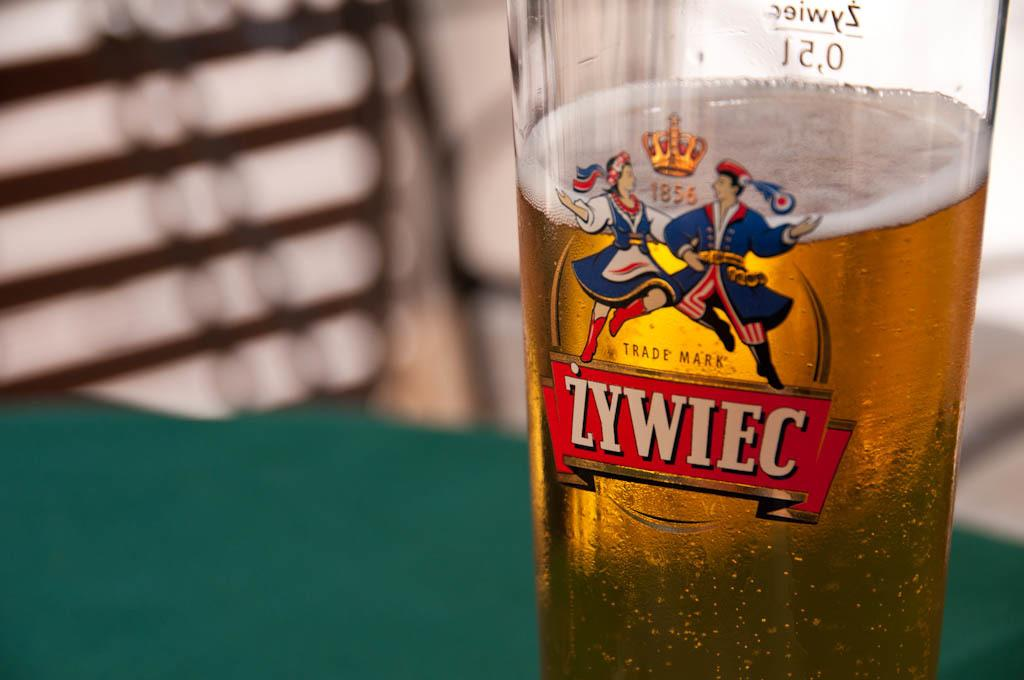What is in the glass that is visible in the image? There is some liquid in the glass in the image. What is the glass placed on in the image? The glass is on an object in the image. Can you describe the background of the image? The background of the image is blurred. What type of bread can be seen on the sand in the image? There is no bread or sand present in the image; it only features a glass with liquid and a blurred background. 